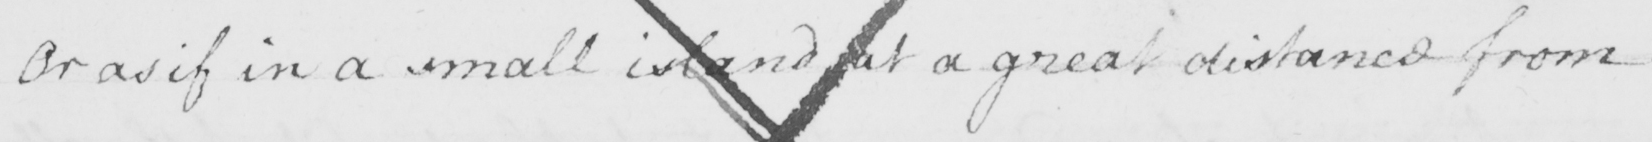Can you read and transcribe this handwriting? Or as if in a small island at a great distance from 